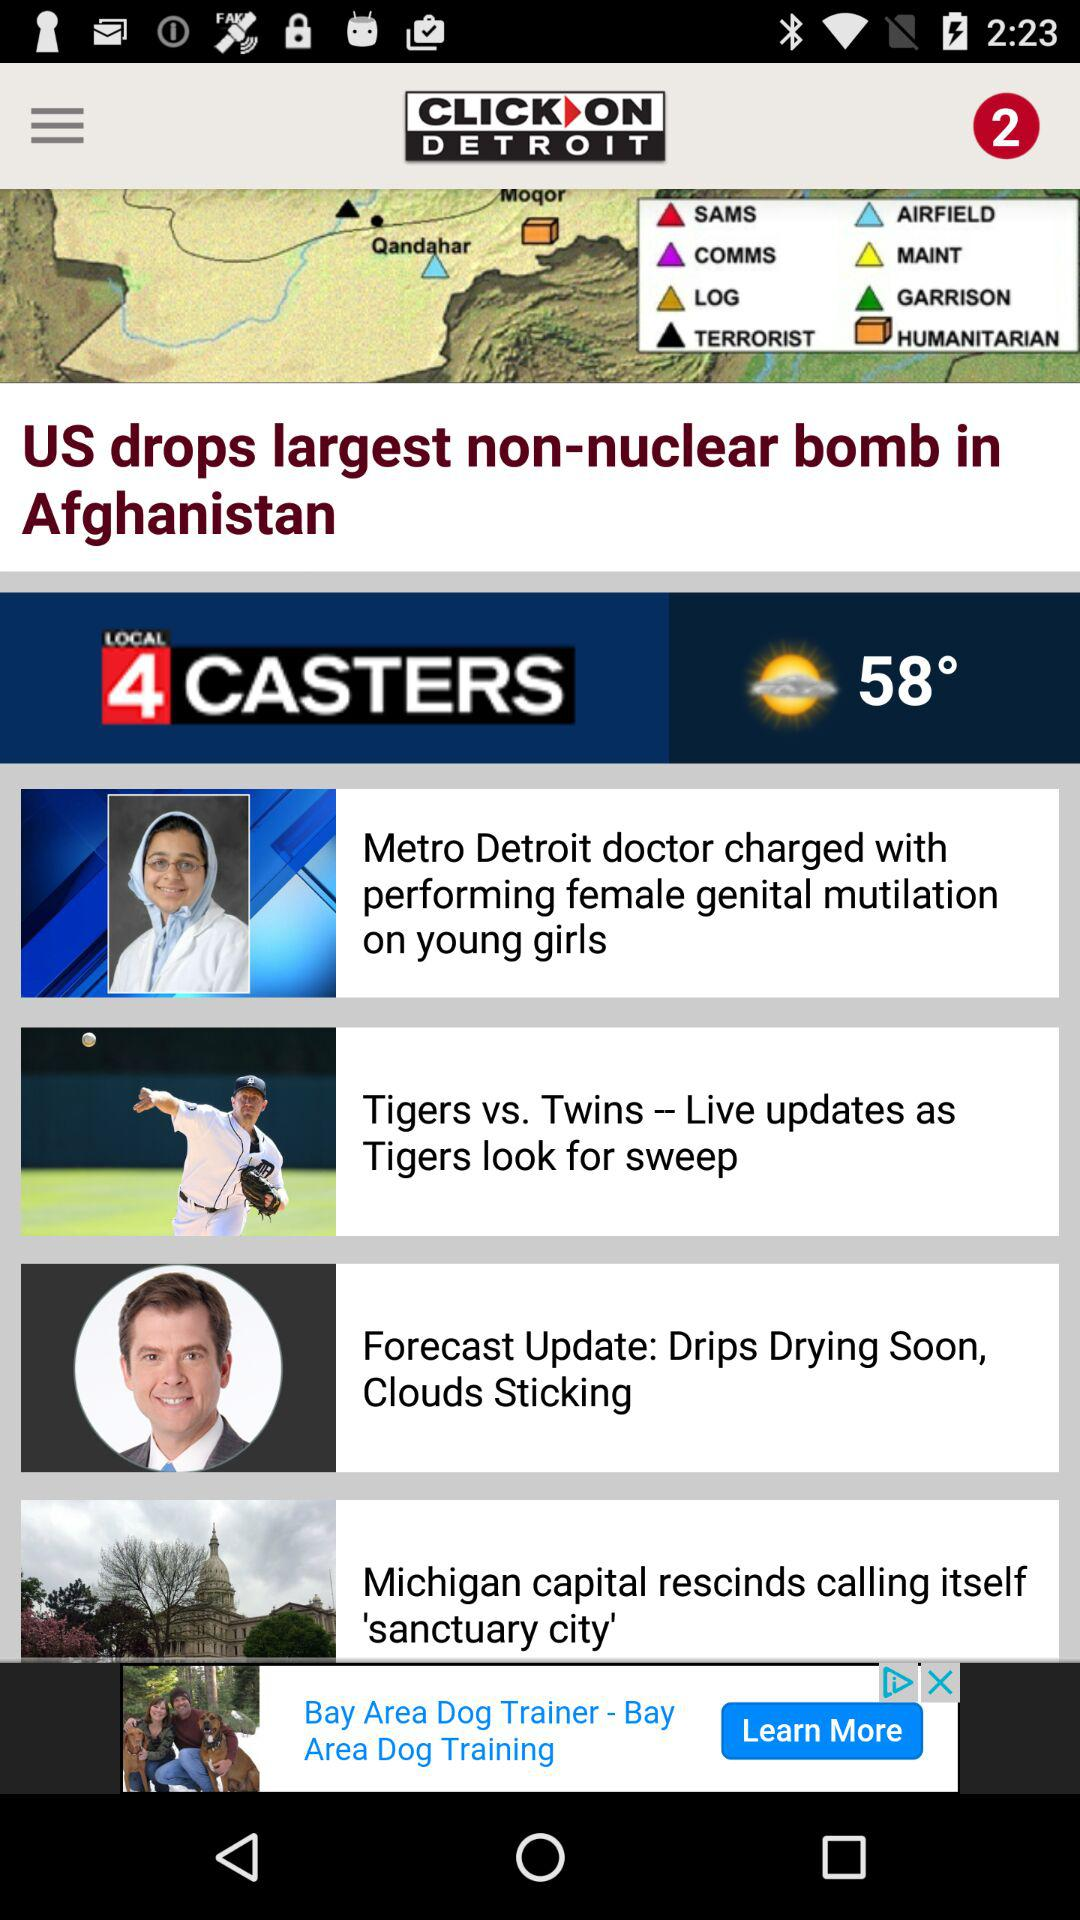What is the application name? The application name is "CLICK ON DETROIT". 